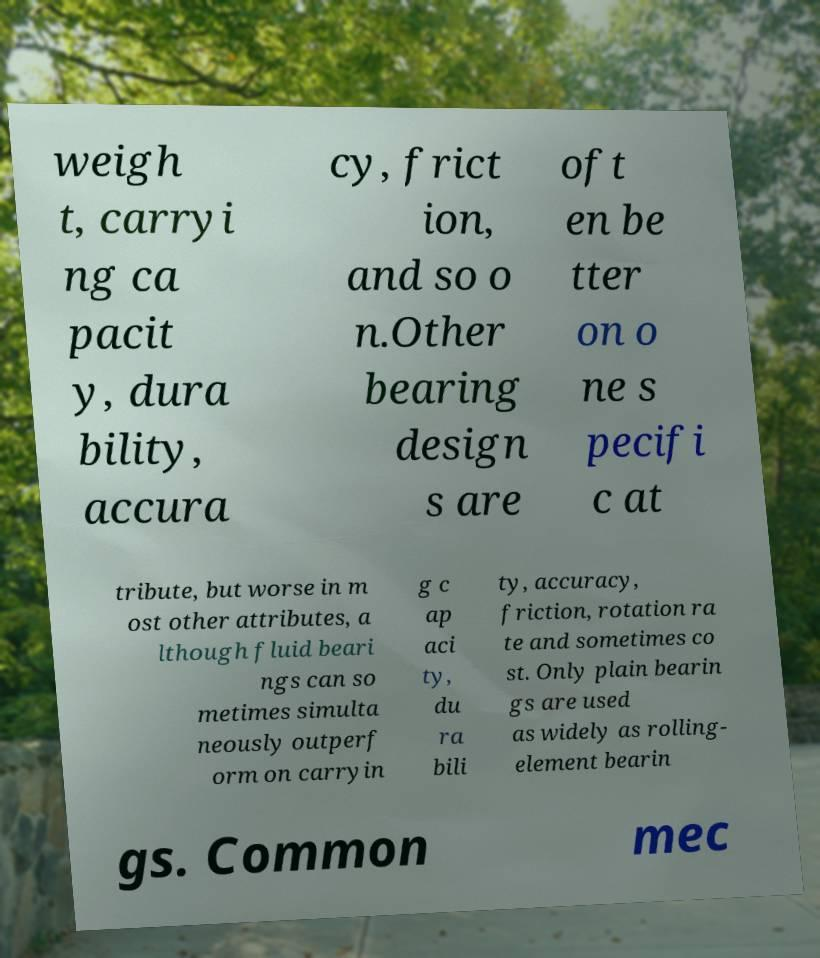Could you assist in decoding the text presented in this image and type it out clearly? weigh t, carryi ng ca pacit y, dura bility, accura cy, frict ion, and so o n.Other bearing design s are oft en be tter on o ne s pecifi c at tribute, but worse in m ost other attributes, a lthough fluid beari ngs can so metimes simulta neously outperf orm on carryin g c ap aci ty, du ra bili ty, accuracy, friction, rotation ra te and sometimes co st. Only plain bearin gs are used as widely as rolling- element bearin gs. Common mec 